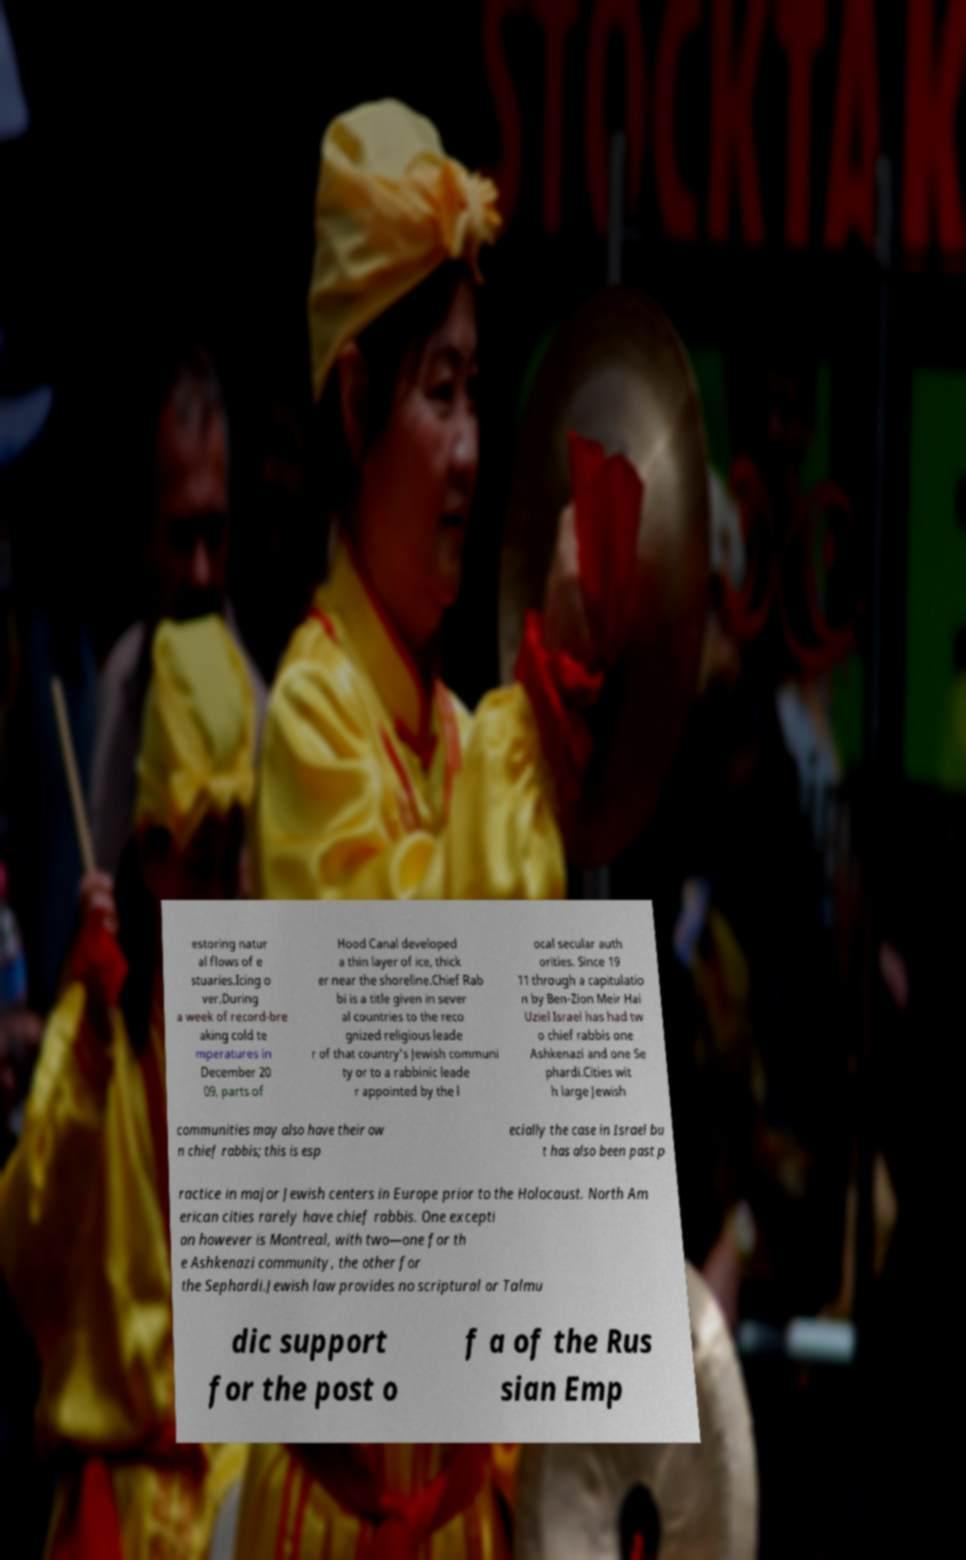Please identify and transcribe the text found in this image. estoring natur al flows of e stuaries.Icing o ver.During a week of record-bre aking cold te mperatures in December 20 09, parts of Hood Canal developed a thin layer of ice, thick er near the shoreline.Chief Rab bi is a title given in sever al countries to the reco gnized religious leade r of that country's Jewish communi ty or to a rabbinic leade r appointed by the l ocal secular auth orities. Since 19 11 through a capitulatio n by Ben-Zion Meir Hai Uziel Israel has had tw o chief rabbis one Ashkenazi and one Se phardi.Cities wit h large Jewish communities may also have their ow n chief rabbis; this is esp ecially the case in Israel bu t has also been past p ractice in major Jewish centers in Europe prior to the Holocaust. North Am erican cities rarely have chief rabbis. One excepti on however is Montreal, with two—one for th e Ashkenazi community, the other for the Sephardi.Jewish law provides no scriptural or Talmu dic support for the post o f a of the Rus sian Emp 